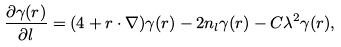Convert formula to latex. <formula><loc_0><loc_0><loc_500><loc_500>\frac { \partial \gamma ( r ) } { \partial l } = ( 4 + { r } \cdot \nabla ) \gamma ( r ) - 2 n _ { l } \gamma ( r ) - C \lambda ^ { 2 } \gamma ( r ) ,</formula> 